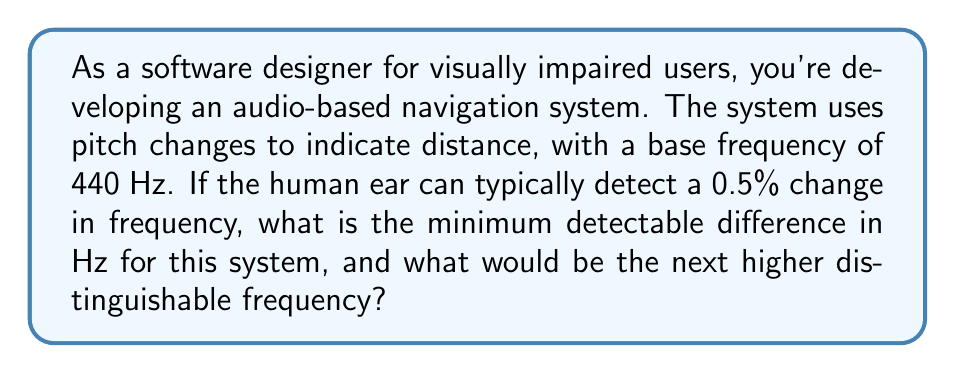Give your solution to this math problem. Let's approach this step-by-step:

1) The base frequency is 440 Hz.

2) The minimum detectable change is 0.5% or 0.005 in decimal form.

3) To calculate the minimum detectable difference in Hz:
   $$\text{Difference} = 440 \text{ Hz} \times 0.005 = 2.2 \text{ Hz}$$

4) To find the next higher distinguishable frequency, we add this difference to the base frequency:
   $$\text{Next frequency} = 440 \text{ Hz} + 2.2 \text{ Hz} = 442.2 \text{ Hz}$$

5) Therefore, the minimum detectable difference is 2.2 Hz, and the next higher distinguishable frequency is 442.2 Hz.
Answer: 2.2 Hz; 442.2 Hz 